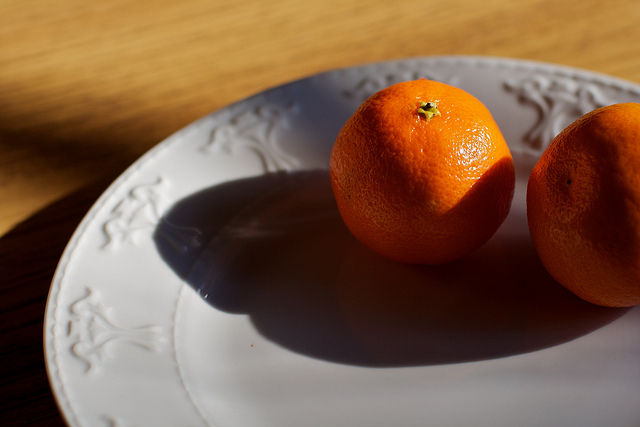Describe a realistic scenario involving this image in a long response. The image represents a tranquil morning in a rustic home. The table is set with a pristine white plate, adorned with an intricate pattern, holding two fresh oranges. These oranges were probably picked from the local market or even their own backyard. Sunlight streams in through the window, casting soft shadows and illuminating the fresh fruits, ready to be peeled and enjoyed as part of a wholesome breakfast. The setting suggests a moment of simple pleasure and the appreciation of nature's bounty in the comfort of one's home. 